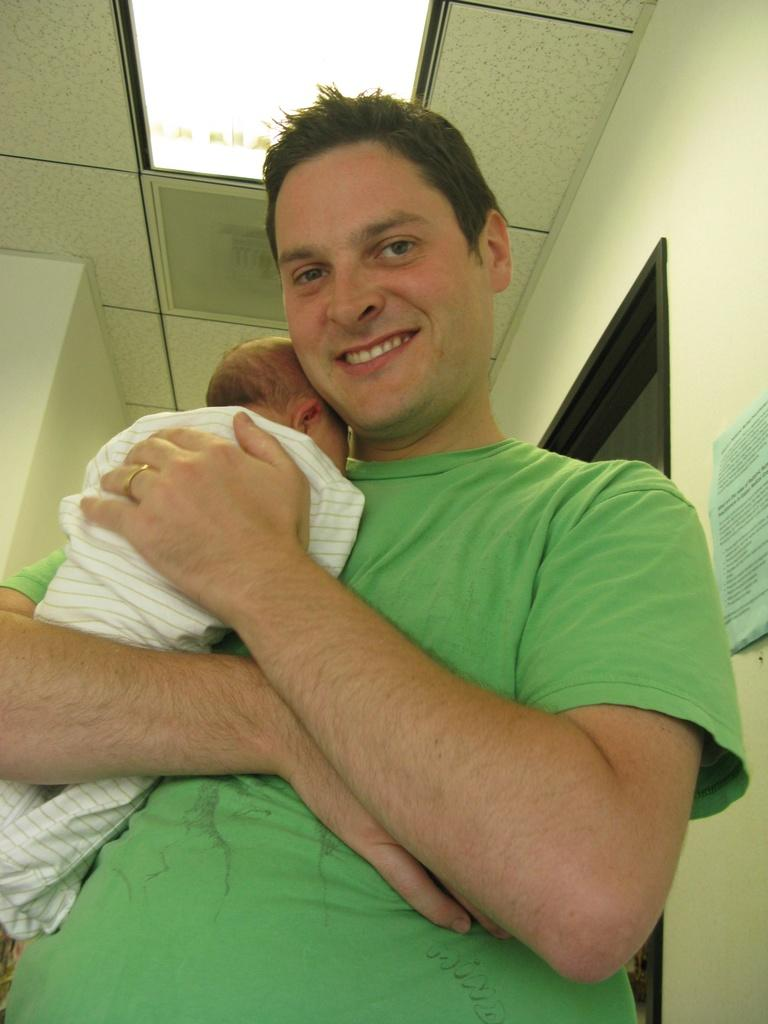What is happening in the center of the image? There is a person holding a baby in the center of the image. What can be seen at the top of the image? There is a ceiling with lights at the top of the image. What is located to the right side of the image? There is a wall to the right side of the image. What type of beef is being cooked in the image? There is no beef present in the image; it features a person holding a baby. How does the person's breath affect the baby in the image? The image does not show the person's breath or any indication of its effect on the baby. 